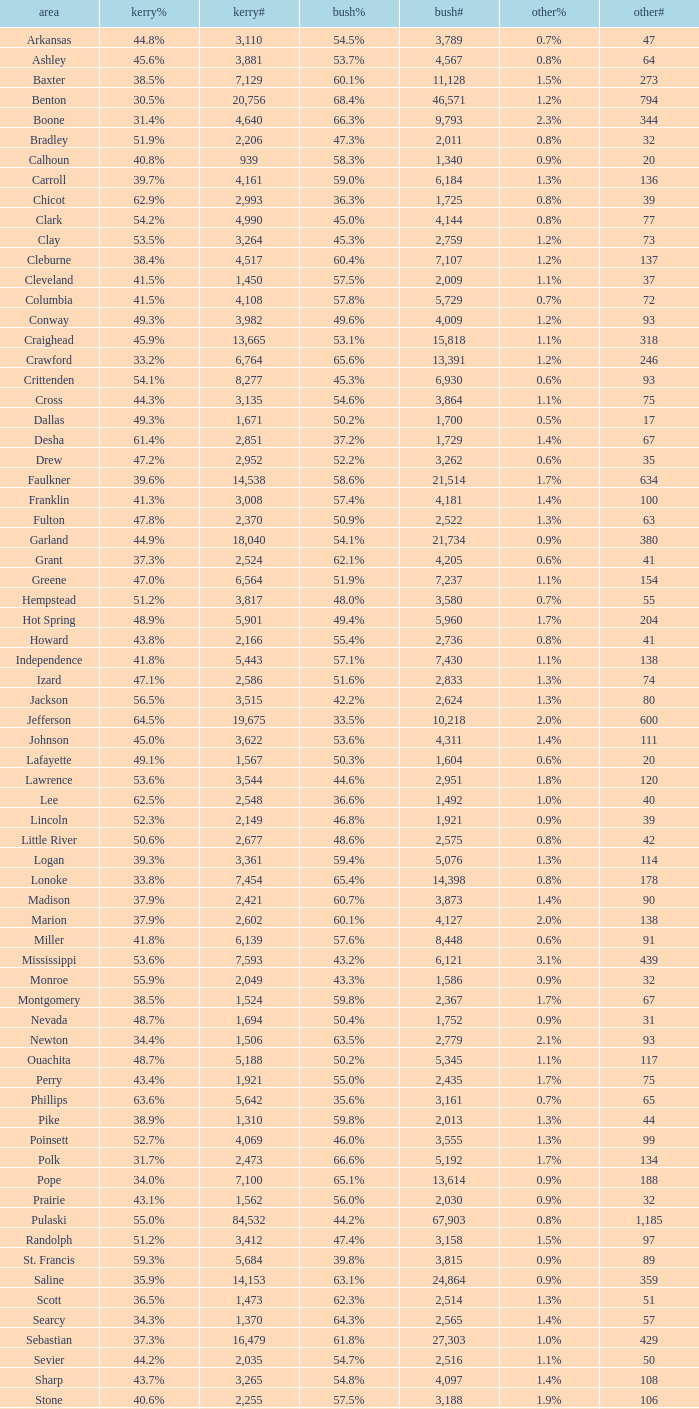When bush% is "65.4%", what is the smallest bush#? 14398.0. 